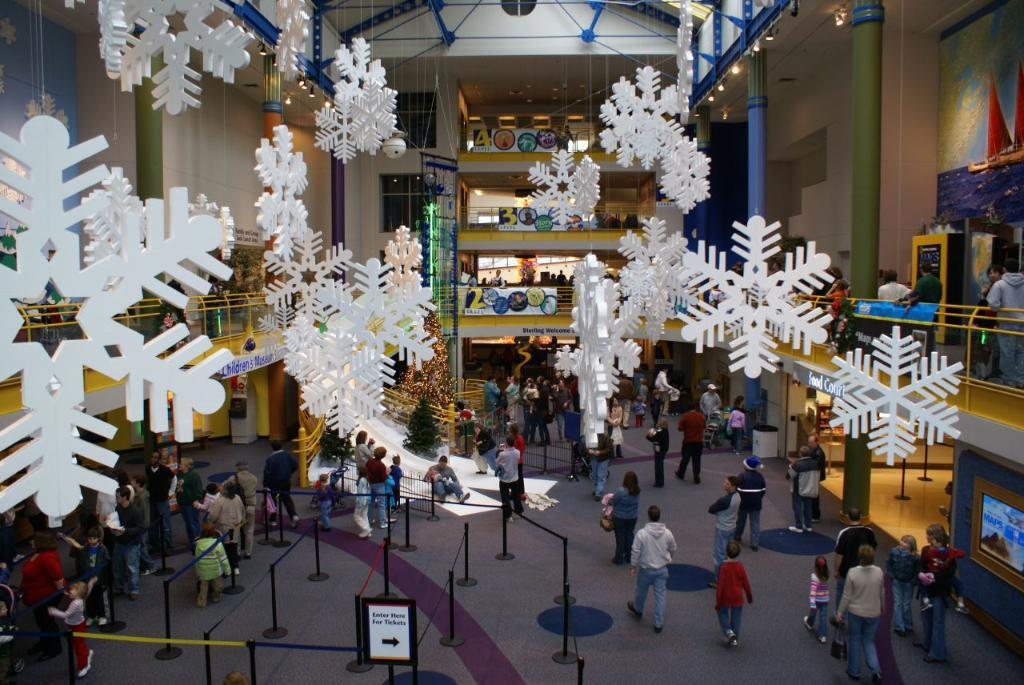What is happening in the image involving the group of people? In the image, some people in the group are walking, while others are standing. Can you describe the actions of the people in the group? Yes, some people are walking, and some are standing. What can be seen in the background of the image? There are pillars visible in the background of the image. Where is the faucet located in the image? There is no faucet present in the image. What type of machine is being used by the people in the image? There is no machine visible in the image; the people are walking or standing. 